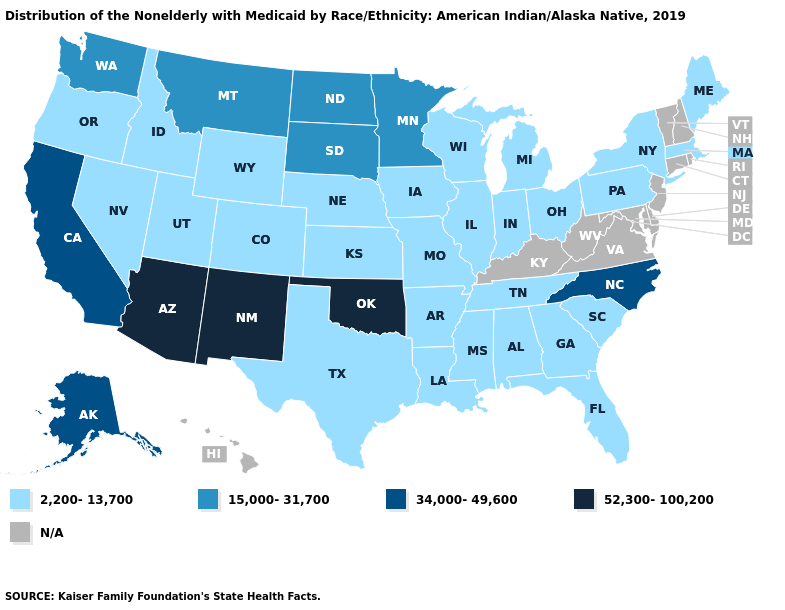Which states have the lowest value in the South?
Write a very short answer. Alabama, Arkansas, Florida, Georgia, Louisiana, Mississippi, South Carolina, Tennessee, Texas. What is the value of Michigan?
Concise answer only. 2,200-13,700. Name the states that have a value in the range 15,000-31,700?
Answer briefly. Minnesota, Montana, North Dakota, South Dakota, Washington. What is the value of North Dakota?
Keep it brief. 15,000-31,700. Does the map have missing data?
Quick response, please. Yes. What is the value of Georgia?
Answer briefly. 2,200-13,700. What is the value of Pennsylvania?
Keep it brief. 2,200-13,700. What is the value of New Jersey?
Quick response, please. N/A. What is the value of Hawaii?
Concise answer only. N/A. Which states have the highest value in the USA?
Answer briefly. Arizona, New Mexico, Oklahoma. Which states have the lowest value in the USA?
Answer briefly. Alabama, Arkansas, Colorado, Florida, Georgia, Idaho, Illinois, Indiana, Iowa, Kansas, Louisiana, Maine, Massachusetts, Michigan, Mississippi, Missouri, Nebraska, Nevada, New York, Ohio, Oregon, Pennsylvania, South Carolina, Tennessee, Texas, Utah, Wisconsin, Wyoming. How many symbols are there in the legend?
Keep it brief. 5. Name the states that have a value in the range 52,300-100,200?
Be succinct. Arizona, New Mexico, Oklahoma. What is the value of Colorado?
Be succinct. 2,200-13,700. 